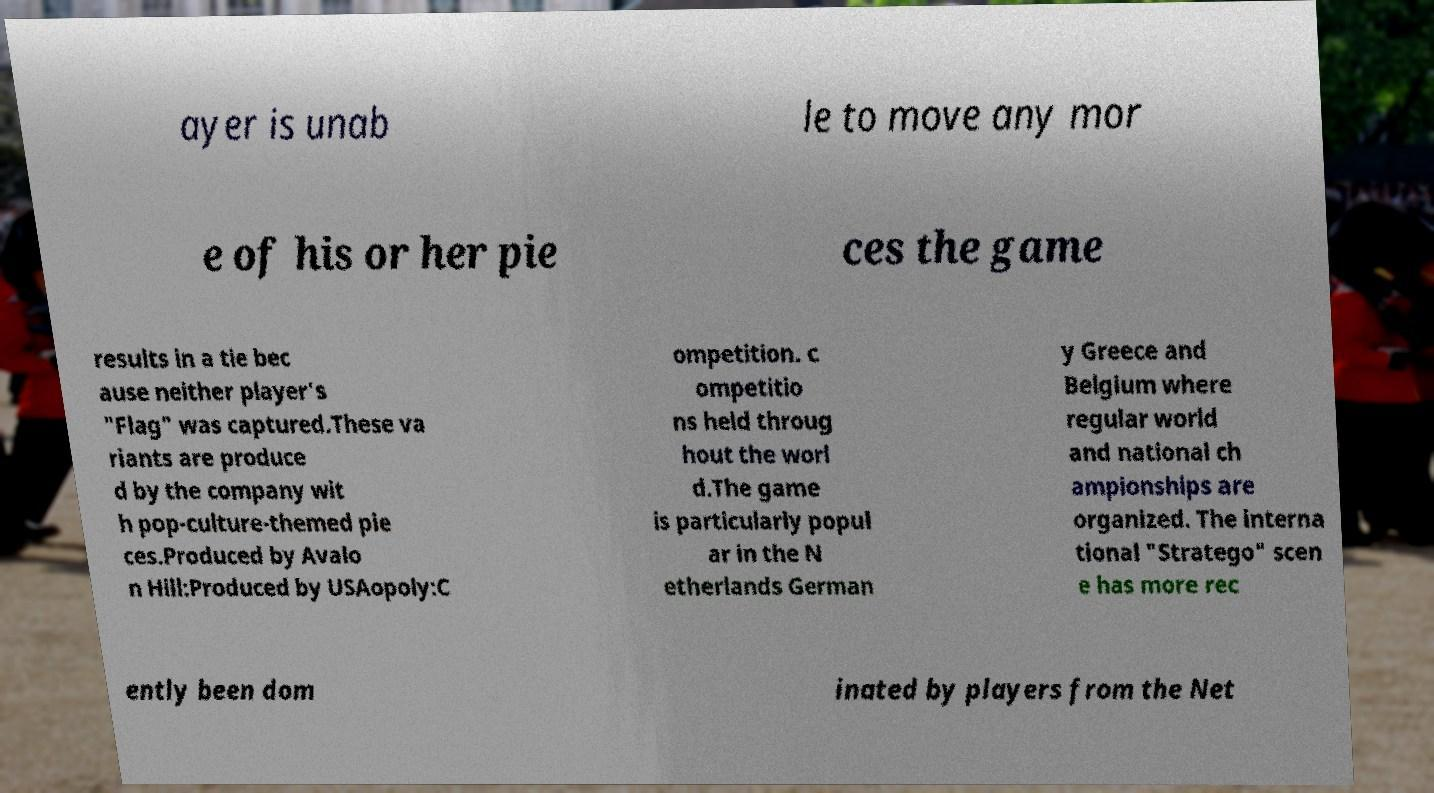What messages or text are displayed in this image? I need them in a readable, typed format. ayer is unab le to move any mor e of his or her pie ces the game results in a tie bec ause neither player's "Flag" was captured.These va riants are produce d by the company wit h pop-culture-themed pie ces.Produced by Avalo n Hill:Produced by USAopoly:C ompetition. c ompetitio ns held throug hout the worl d.The game is particularly popul ar in the N etherlands German y Greece and Belgium where regular world and national ch ampionships are organized. The interna tional "Stratego" scen e has more rec ently been dom inated by players from the Net 